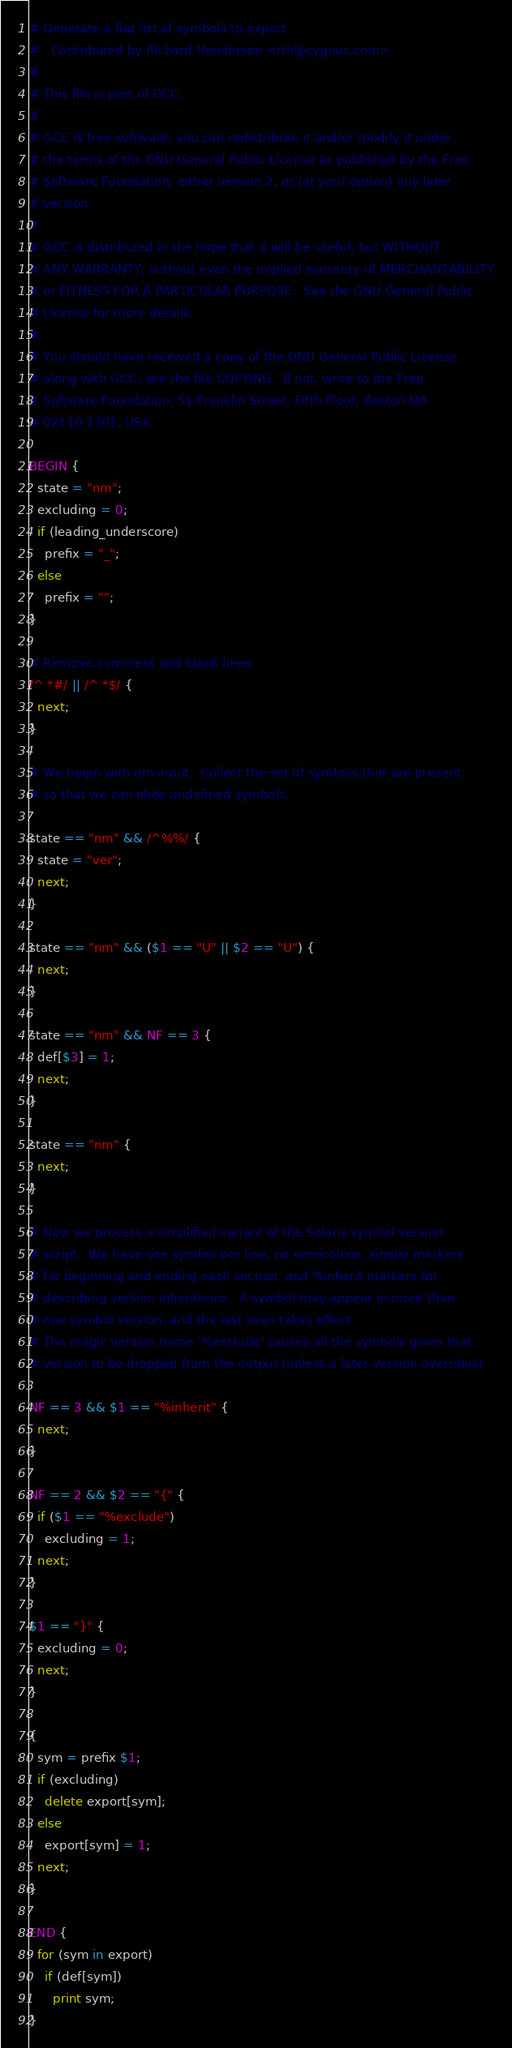<code> <loc_0><loc_0><loc_500><loc_500><_Awk_># Generate a flat list of symbols to export.
#	Contributed by Richard Henderson <rth@cygnus.com>
#
# This file is part of GCC.
#
# GCC is free software; you can redistribute it and/or modify it under
# the terms of the GNU General Public License as published by the Free
# Software Foundation; either version 2, or (at your option) any later
# version.
#
# GCC is distributed in the hope that it will be useful, but WITHOUT
# ANY WARRANTY; without even the implied warranty of MERCHANTABILITY
# or FITNESS FOR A PARTICULAR PURPOSE.  See the GNU General Public
# License for more details.
#
# You should have received a copy of the GNU General Public License
# along with GCC; see the file COPYING.  If not, write to the Free
# Software Foundation, 51 Franklin Street, Fifth Floor, Boston MA
# 02110-1301, USA.

BEGIN {
  state = "nm";
  excluding = 0;
  if (leading_underscore)
    prefix = "_";
  else
    prefix = "";
}

# Remove comment and blank lines.
/^ *#/ || /^ *$/ {
  next;
}

# We begin with nm input.  Collect the set of symbols that are present
# so that we can elide undefined symbols.

state == "nm" && /^%%/ {
  state = "ver";
  next;
}

state == "nm" && ($1 == "U" || $2 == "U") {
  next;
}

state == "nm" && NF == 3 {
  def[$3] = 1;
  next;
}

state == "nm" {
  next;
}

# Now we process a simplified variant of the Solaris symbol version
# script.  We have one symbol per line, no semicolons, simple markers
# for beginning and ending each section, and %inherit markers for
# describing version inheritence.  A symbol may appear in more than
# one symbol version, and the last seen takes effect.
# The magic version name '%exclude' causes all the symbols given that
# version to be dropped from the output (unless a later version overrides).

NF == 3 && $1 == "%inherit" {
  next;
}

NF == 2 && $2 == "{" {
  if ($1 == "%exclude")
    excluding = 1;
  next;
}

$1 == "}" {
  excluding = 0;
  next;
}

{
  sym = prefix $1;
  if (excluding)
    delete export[sym];
  else
    export[sym] = 1;
  next;
}

END {
  for (sym in export)
    if (def[sym])
      print sym;
}
</code> 